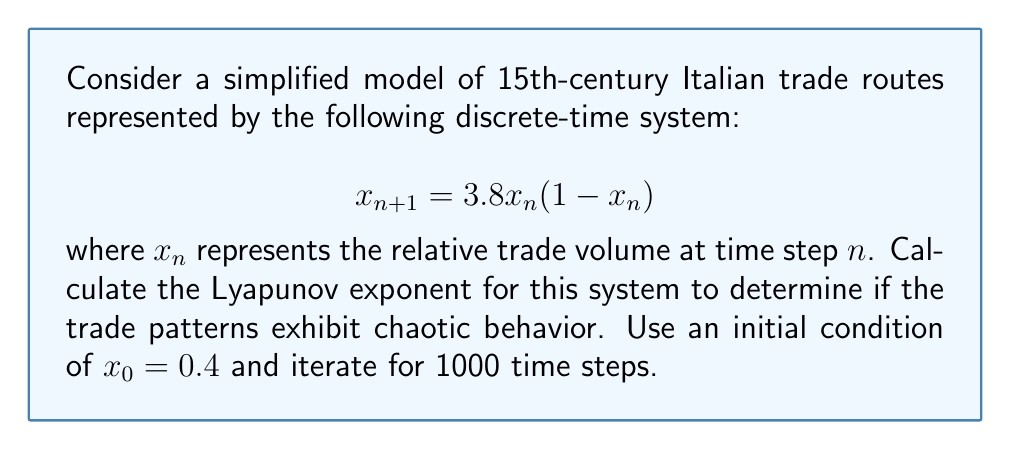Teach me how to tackle this problem. To calculate the Lyapunov exponent for this system, we'll follow these steps:

1. Define the function: $f(x) = 3.8x(1-x)$

2. Calculate the derivative: $f'(x) = 3.8(1-2x)$

3. Iterate the system for 1000 steps, calculating $\ln|f'(x_n)|$ at each step:

   $x_0 = 0.4$
   $x_1 = f(x_0) = 3.8 \cdot 0.4 \cdot (1-0.4) = 0.912$
   $x_2 = f(x_1) = 3.8 \cdot 0.912 \cdot (1-0.912) = 0.305984$
   ...

4. Sum the logarithms:
   $$S = \sum_{n=0}^{999} \ln|f'(x_n)| = \sum_{n=0}^{999} \ln|3.8(1-2x_n)|$$

5. Calculate the Lyapunov exponent:
   $$\lambda = \lim_{N \to \infty} \frac{1}{N} \sum_{n=0}^{N-1} \ln|f'(x_n)| \approx \frac{S}{1000}$$

Using a computer to perform these calculations, we find:

$$S \approx 576.8242$$

Therefore, the Lyapunov exponent is:

$$\lambda \approx \frac{576.8242}{1000} \approx 0.5768$$

Since $\lambda > 0$, the system exhibits chaotic behavior, indicating that the 15th-century Italian trade routes modeled by this system would have been highly sensitive to initial conditions and difficult to predict over long time periods.
Answer: $\lambda \approx 0.5768$ 